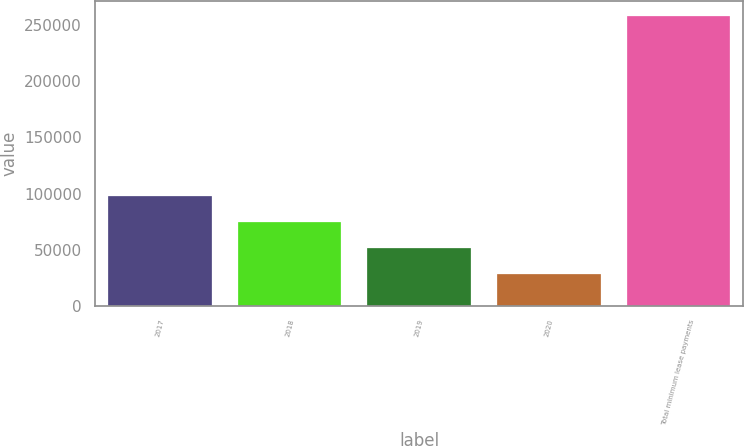Convert chart to OTSL. <chart><loc_0><loc_0><loc_500><loc_500><bar_chart><fcel>2017<fcel>2018<fcel>2019<fcel>2020<fcel>Total minimum lease payments<nl><fcel>97534.1<fcel>74546.4<fcel>51558.7<fcel>28571<fcel>258448<nl></chart> 